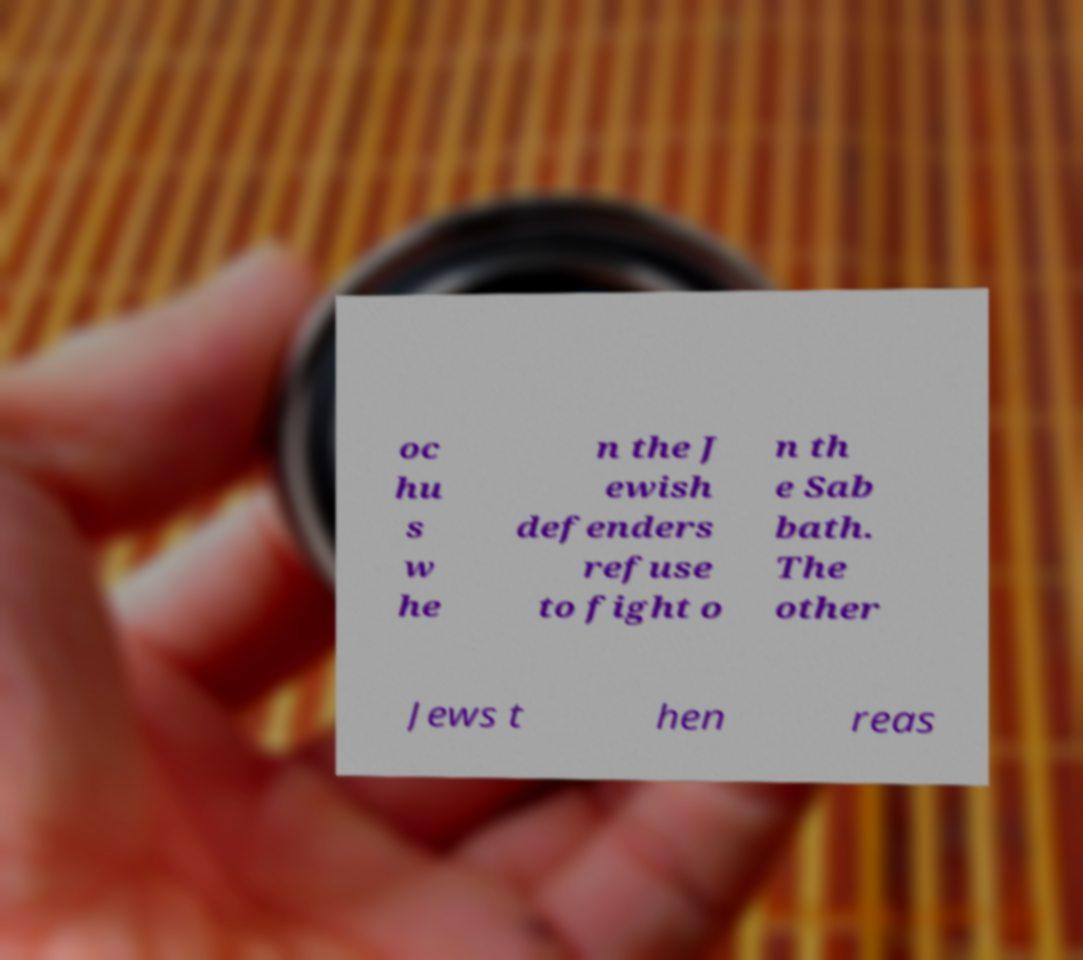There's text embedded in this image that I need extracted. Can you transcribe it verbatim? oc hu s w he n the J ewish defenders refuse to fight o n th e Sab bath. The other Jews t hen reas 